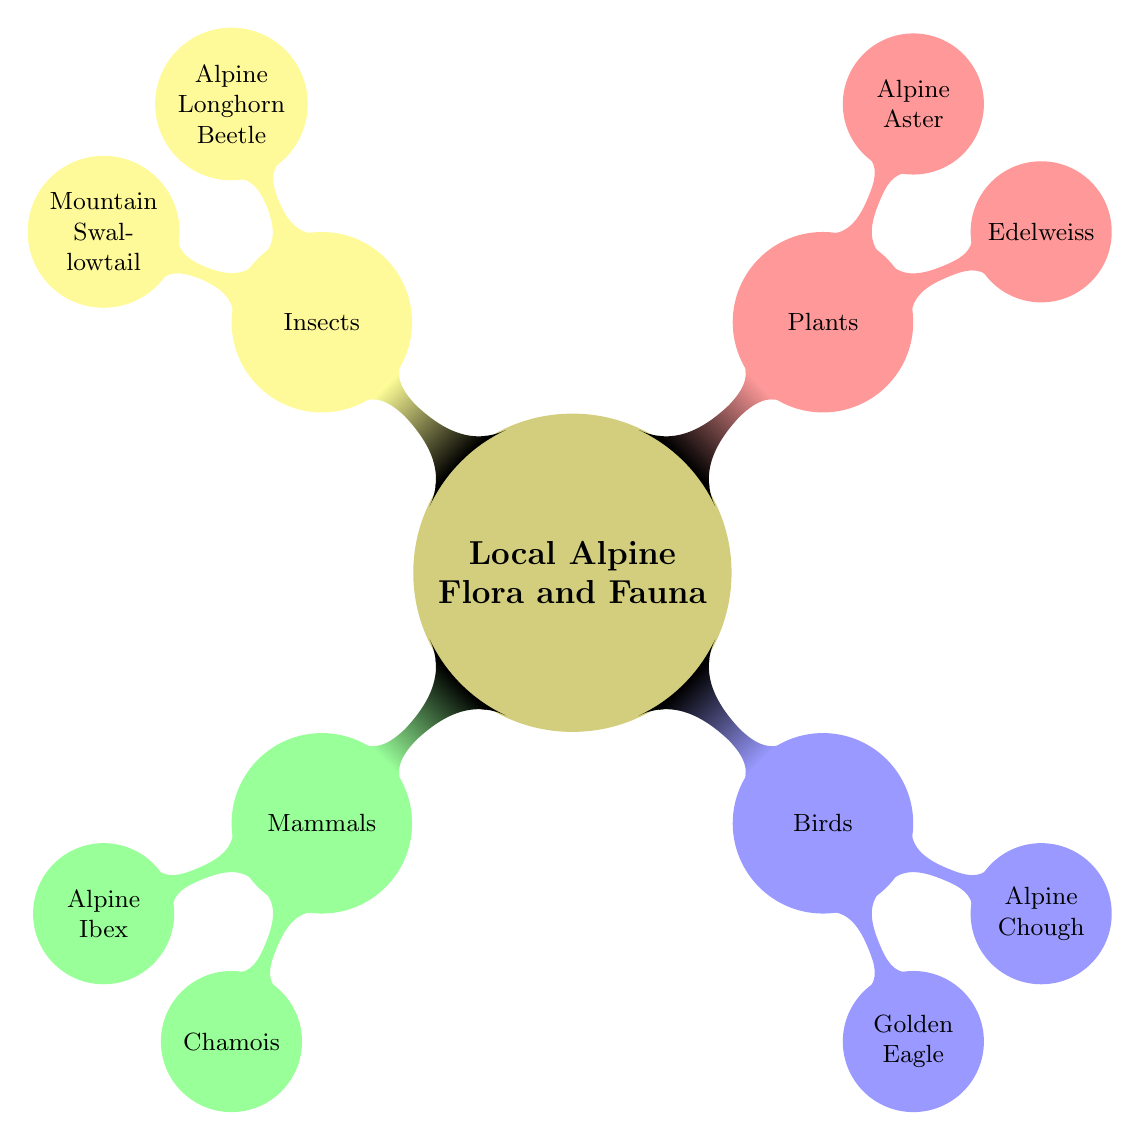What are the two main categories of Local Alpine Flora and Fauna? The diagram represents four main categories: Mammals, Birds, Plants, and Insects. To answer the question, I focused on identifying the primary branches of the mind map, which display the main categories clearly.
Answer: Mammals, Birds Which mammal is characterized by long curved horns? This information is found under the "Mammals" category where Alpine Ibex is listed alongside Chamois. The specific characteristic mentioned for Alpine Ibex is the long curved horns.
Answer: Alpine Ibex How many birds are featured in the mind map? From the "Birds" section, both the Golden Eagle and the Alpine Chough are noted. By counting these two entries under the birds category, the answer is determined.
Answer: 2 What color are the flowers of the Alpine Aster? In the "Plants" section, the describes that Alpine Aster has purple or blue daisy-like flowers. This is a direct connection within the plant category that provides the specific color information needed for this question.
Answer: Purple or blue Which insect is known for its striking black and yellow markings? The diagram specifies that the Mountain Swallowtail, listed under "Insects," is recognized for its striking black and yellow markings. This direct relationship from the insect section leads to the answer.
Answer: Mountain Swallowtail What unique feature does the Alpine Longhorn Beetle have? The Alpine Longhorn Beetle, identified under "Insects," is noted for its long antennae and bright body patterns. By cross-referencing this specific insect with its associated features, the answer is obtained.
Answer: Long antennae Which bird has a wingspan of up to 2.3 meters? Within the "Birds" category, the Golden Eagle is described as having a large wingspan, which directly answers the question about its measurement.
Answer: Golden Eagle What is the primary habitat of the Edelweiss? The diagram indicates that Edelweiss is often found in rocky limestone areas. By analyzing the description of the plant, the habitat is clearly identified.
Answer: Rocky limestone areas 